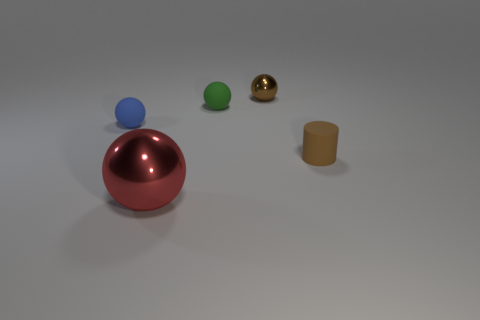Is there any other thing that is the same size as the red thing?
Provide a succinct answer. No. There is a object that is the same color as the cylinder; what is its shape?
Provide a succinct answer. Sphere. Is there anything else that is made of the same material as the red thing?
Provide a short and direct response. Yes. Do the brown object in front of the blue rubber object and the metallic object that is on the left side of the brown ball have the same shape?
Provide a short and direct response. No. How many big things are there?
Offer a terse response. 1. What shape is the object that is the same material as the red ball?
Offer a very short reply. Sphere. Is there any other thing that is the same color as the small metallic ball?
Give a very brief answer. Yes. There is a small matte cylinder; does it have the same color as the rubber ball on the right side of the blue object?
Your answer should be compact. No. Are there fewer blue rubber balls left of the tiny blue thing than big purple metal spheres?
Make the answer very short. No. There is a ball that is in front of the tiny brown rubber cylinder; what is its material?
Keep it short and to the point. Metal. 